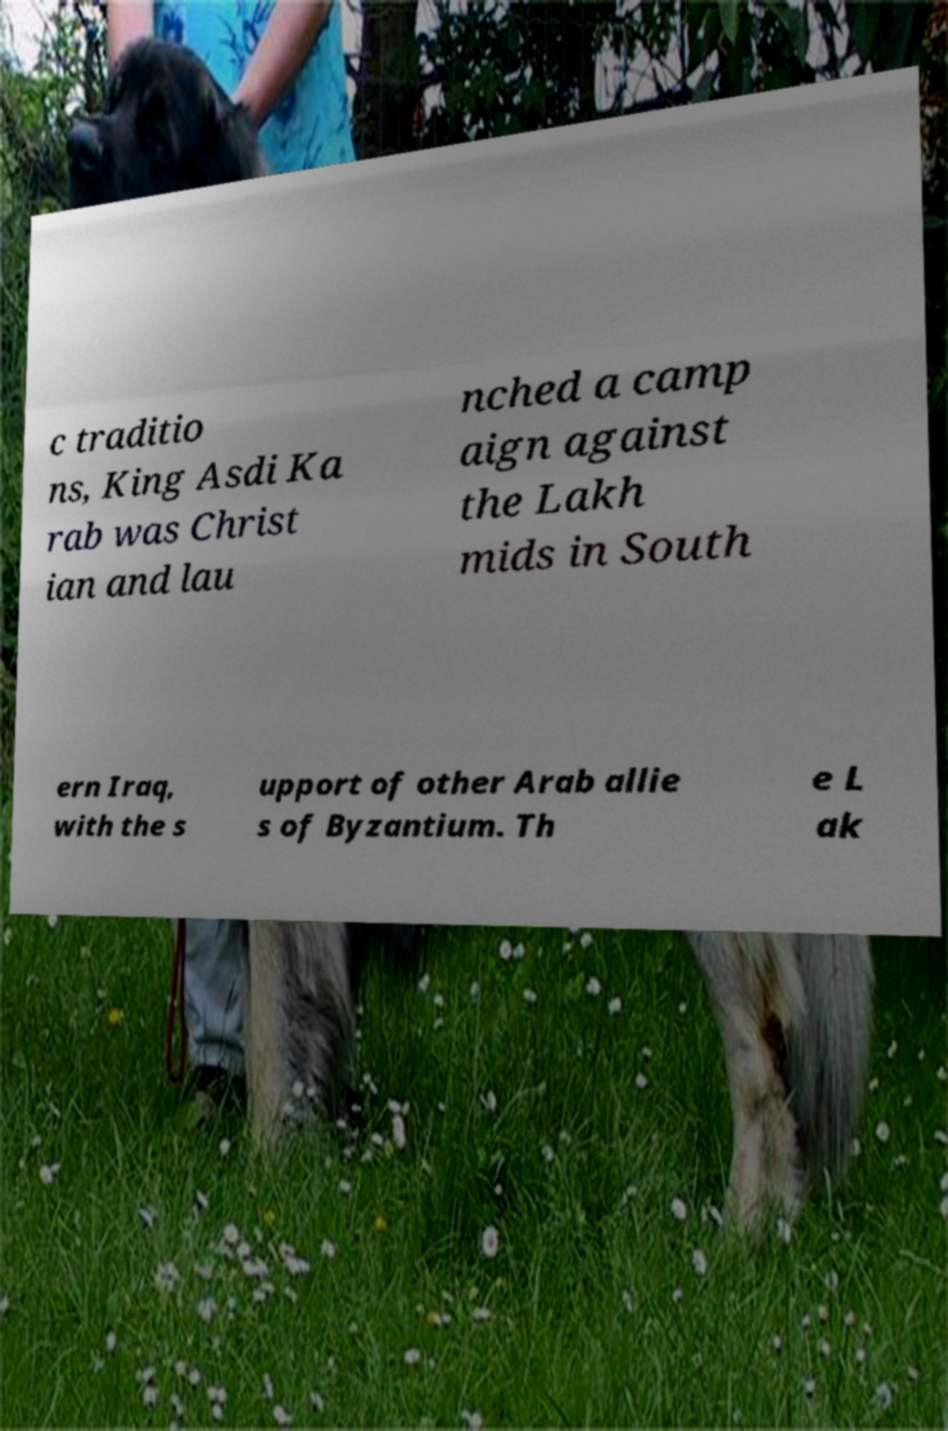Can you read and provide the text displayed in the image?This photo seems to have some interesting text. Can you extract and type it out for me? c traditio ns, King Asdi Ka rab was Christ ian and lau nched a camp aign against the Lakh mids in South ern Iraq, with the s upport of other Arab allie s of Byzantium. Th e L ak 